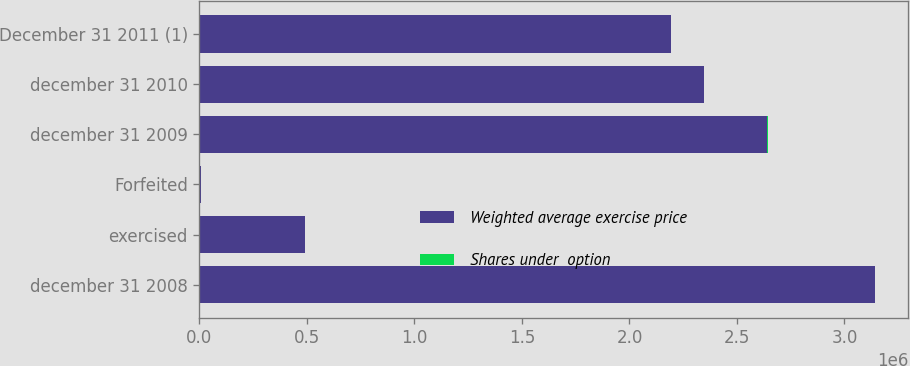Convert chart. <chart><loc_0><loc_0><loc_500><loc_500><stacked_bar_chart><ecel><fcel>december 31 2008<fcel>exercised<fcel>Forfeited<fcel>december 31 2009<fcel>december 31 2010<fcel>December 31 2011 (1)<nl><fcel>Weighted average exercise price<fcel>3.14052e+06<fcel>490617<fcel>8064<fcel>2.64184e+06<fcel>2.34473e+06<fcel>2.19091e+06<nl><fcel>Shares under  option<fcel>88.82<fcel>34.92<fcel>167.76<fcel>98.59<fcel>105.6<fcel>105.33<nl></chart> 